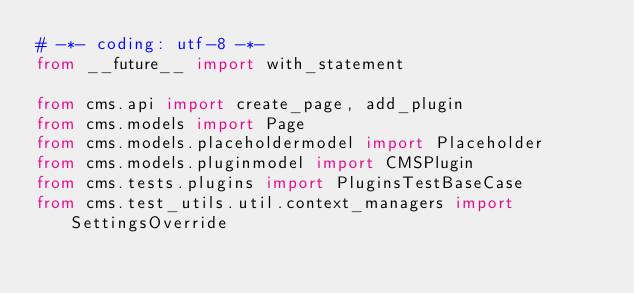Convert code to text. <code><loc_0><loc_0><loc_500><loc_500><_Python_># -*- coding: utf-8 -*-
from __future__ import with_statement

from cms.api import create_page, add_plugin
from cms.models import Page
from cms.models.placeholdermodel import Placeholder
from cms.models.pluginmodel import CMSPlugin
from cms.tests.plugins import PluginsTestBaseCase
from cms.test_utils.util.context_managers import SettingsOverride

</code> 